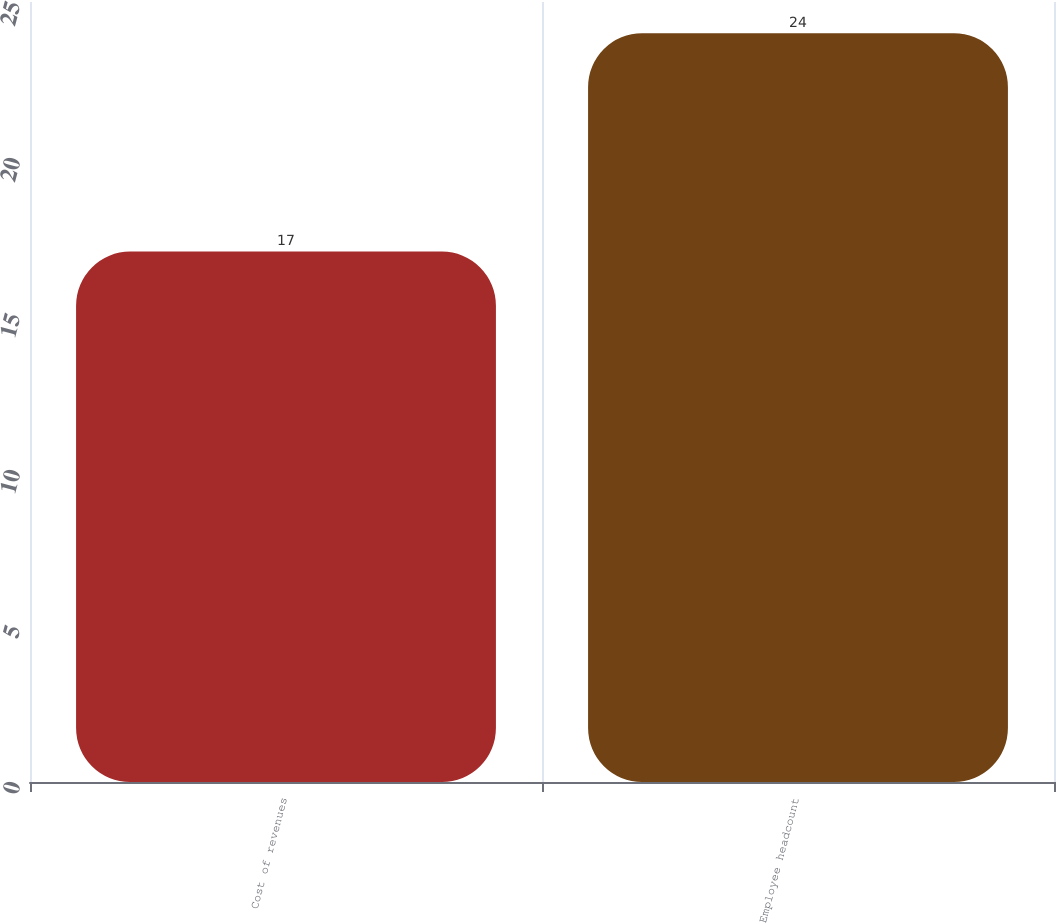<chart> <loc_0><loc_0><loc_500><loc_500><bar_chart><fcel>Cost of revenues<fcel>Employee headcount<nl><fcel>17<fcel>24<nl></chart> 